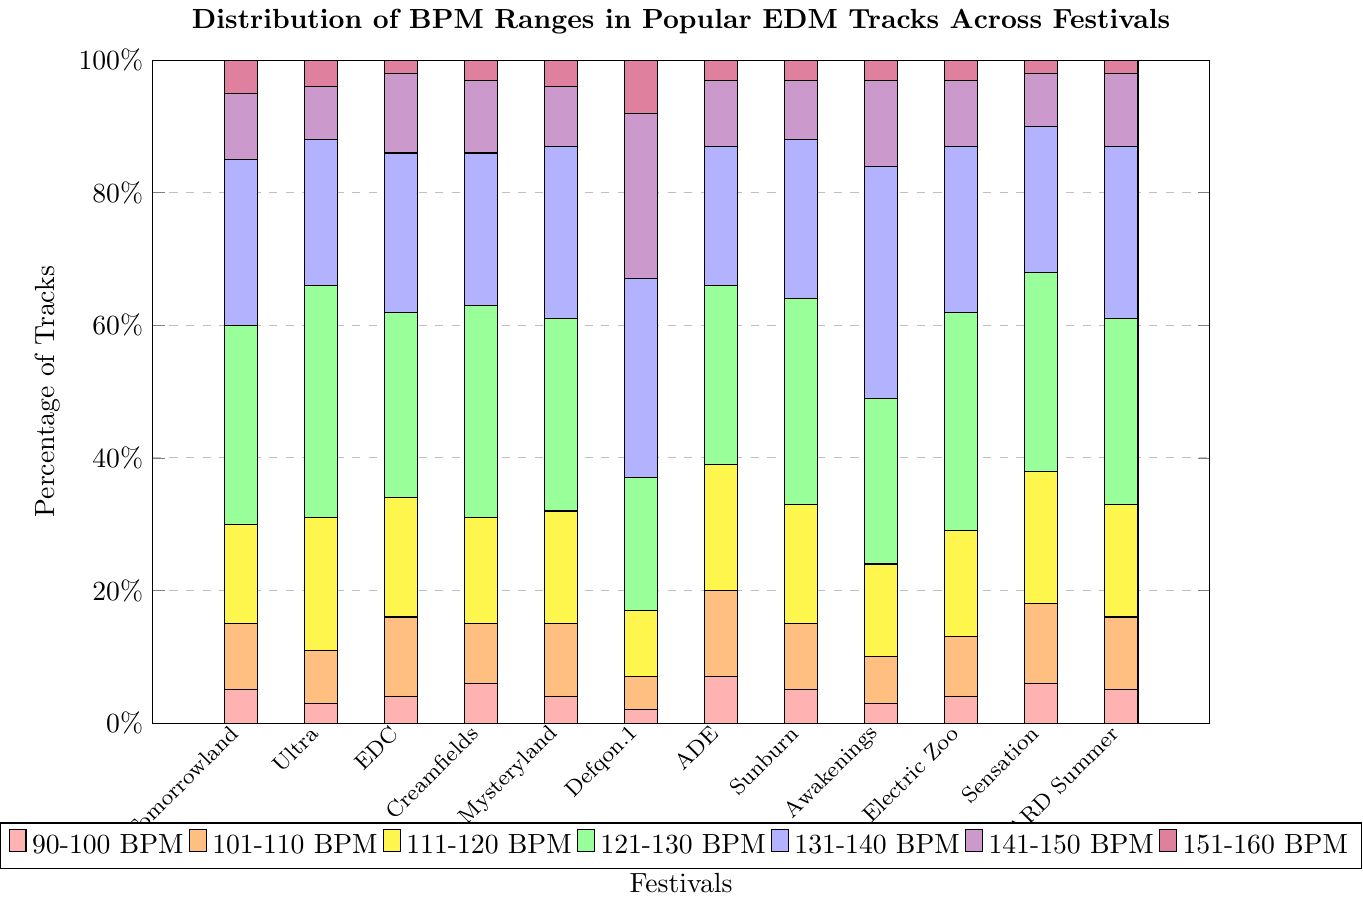What's the festival with the highest percentage of tracks in the 121-130 BPM range? Observe the height of the bars corresponding to the 121-130 BPM range (green color). The highest bar is at Ultra Music Festival.
Answer: Ultra Music Festival Which festival has a higher percentage of tracks in the 141-150 BPM range, Defqon.1 or Electric Daisy Carnival? Look for the bar segments colored violet (141-150 BPM) for both Defqon.1 and Electric Daisy Carnival. Defqon.1's bar is clearly taller than Electric Daisy Carnival's.
Answer: Defqon.1 What is the percentage difference in tracks within the 101-110 BPM range between Tomorrowland and Amsterdam Dance Event? Locate the orange bars (101-110 BPM) for both Tomorrowland and Amsterdam Dance Event. Tomorrowland has 10% and Amsterdam Dance Event has 13%, so the difference is 13% - 10% = 3%.
Answer: 3% How many festivals have their highest percentage of tracks in the 131-140 BPM range? Check the bars colored blue (131-140 BPM) and verify which festivals have these bars as the highest. Festivals with the highest blue bar are Defqon.1 and Awakenings.
Answer: 2 For Creamfields, is the percentage of tracks in the 151-160 BPM range greater than in the 90-100 BPM range? Compare the height of the purple bar (151-160 BPM) with the height of the red bar (90-100 BPM) for Creamfields. The purple bar (3%) is shorter than the red bar (6%).
Answer: No What is the combined percentage of tracks in the 111-120 BPM range for Sunburn Festival and HARD Summer? Look for the yellow bars (111-120 BPM) for both Sunburn Festival and HARD Summer. Sunburn Festival has 18% and HARD Summer has 17%, so their sum is 18% + 17% = 35%.
Answer: 35% Which festival has an equal percentage of tracks in the 121-130 BPM range and the 131-140 BPM range? Find the bars where the height of the green bars (121-130 BPM) equals the height of the blue ones (131-140 BPM). It is Tomorrowland with 30% for both BPM ranges.
Answer: Tomorrowland Is the percentage of tracks in the 101-110 BPM range higher at Sensation or at Electric Zoo? Examine the orange bars (101-110 BPM) for Sensation and Electric Zoo. Sensation's bar is taller (12%) than Electric Zoo's (9%).
Answer: Sensation What is the total percentage of tracks in the 90-100 BPM range across all festivals? Sum the red bar heights for all festivals. The red bars' values are: 5+3+4+6+4+2+7+5+3+4+6+5, which totals to 54%.
Answer: 54% Which festival has the lowest representation in the 111-120 BPM range? Identify the shortest yellow bar (111-120 BPM). Defqon.1 has the lowest value at 10%.
Answer: Defqon.1 